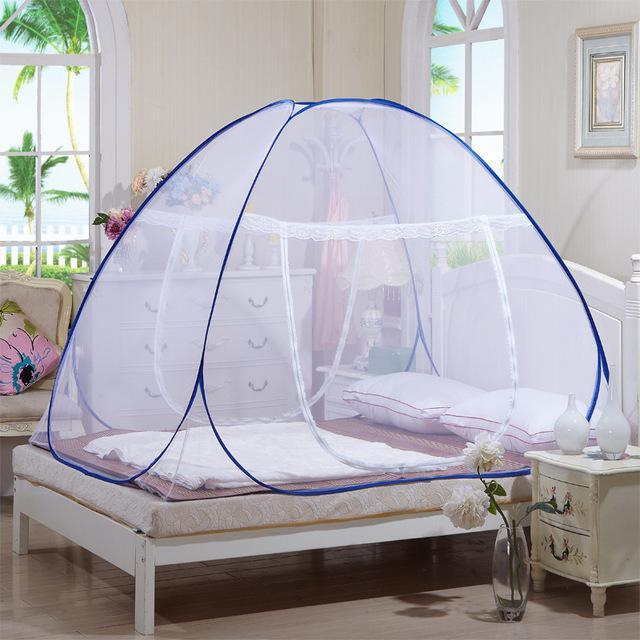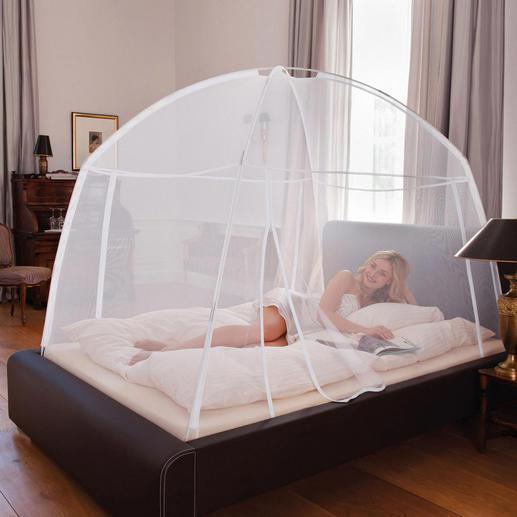The first image is the image on the left, the second image is the image on the right. Analyze the images presented: Is the assertion "Each image shows a canopy with a dome top and trim in a shade of blue over a bed with no one on it." valid? Answer yes or no. No. The first image is the image on the left, the second image is the image on the right. For the images shown, is this caption "One bed net has a fabric bottom trim." true? Answer yes or no. No. 